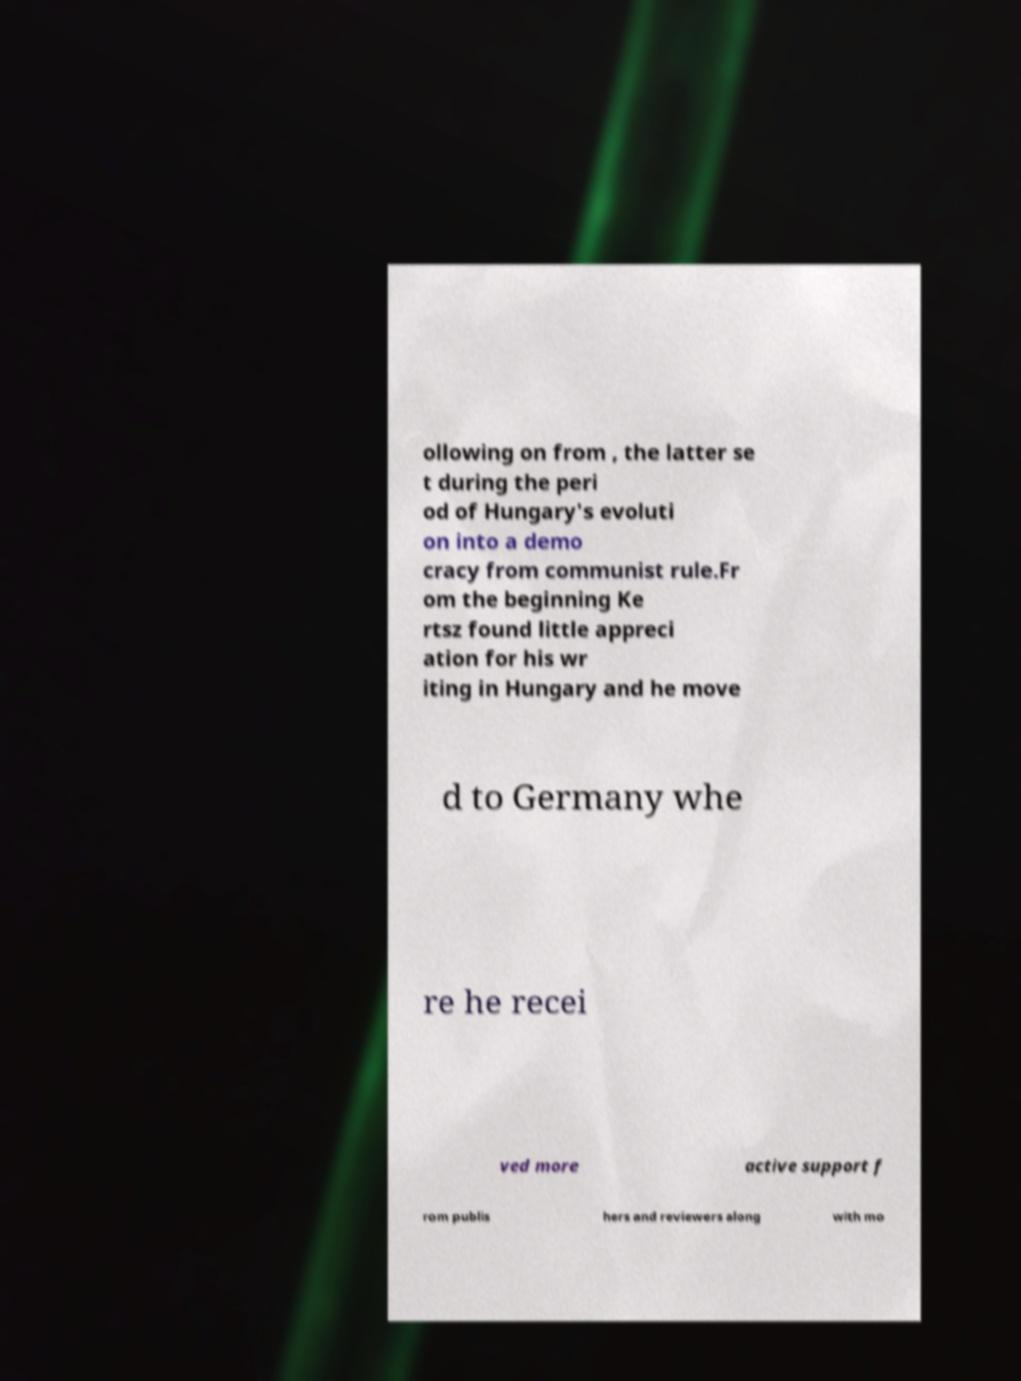I need the written content from this picture converted into text. Can you do that? ollowing on from , the latter se t during the peri od of Hungary's evoluti on into a demo cracy from communist rule.Fr om the beginning Ke rtsz found little appreci ation for his wr iting in Hungary and he move d to Germany whe re he recei ved more active support f rom publis hers and reviewers along with mo 